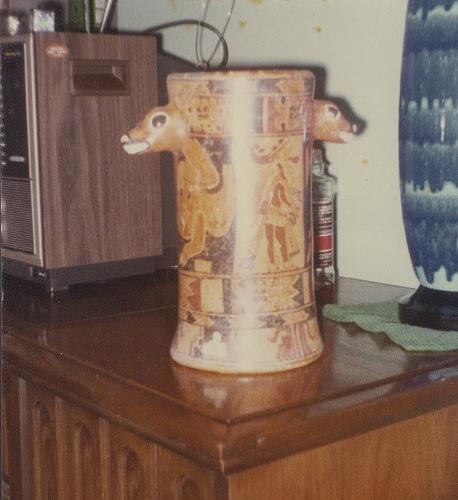How many animal heads are on the vase?
Answer briefly. 2. What country is this sculpture from?
Concise answer only. Egypt. What color is the wall?
Give a very brief answer. White. 